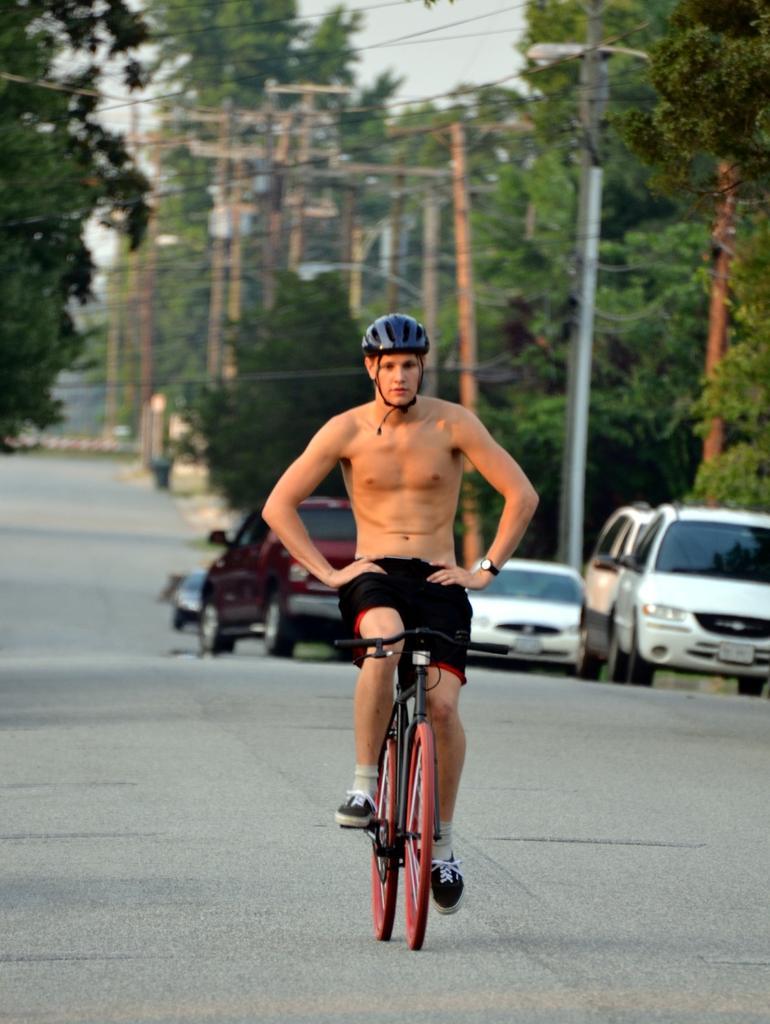In one or two sentences, can you explain what this image depicts? A person is riding bicycle on the road. Behind him there are vehicles,electric poles ,trees and sky. 